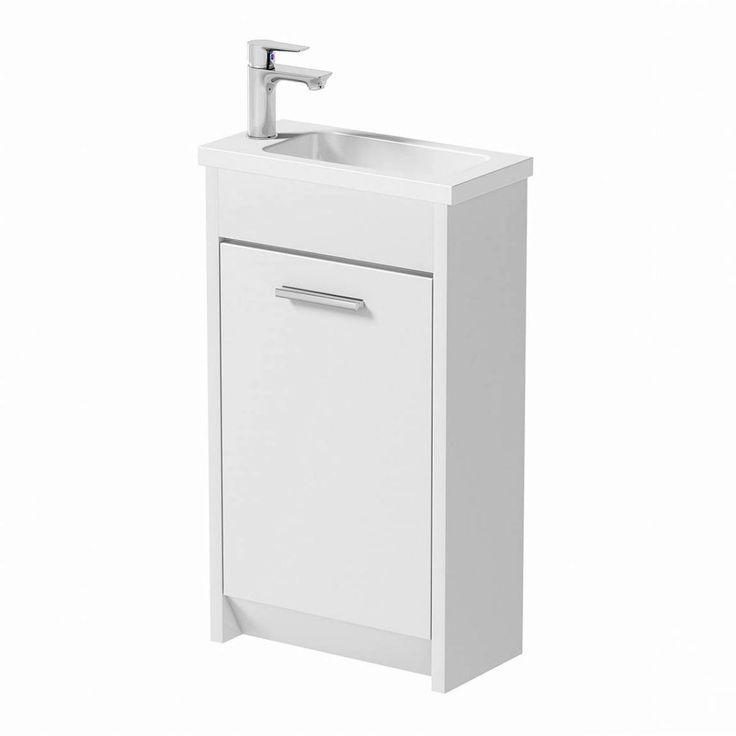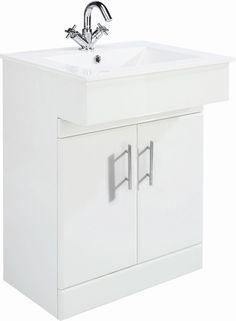The first image is the image on the left, the second image is the image on the right. Analyze the images presented: Is the assertion "The basin in the image on the left is set into a counter." valid? Answer yes or no. Yes. The first image is the image on the left, the second image is the image on the right. Considering the images on both sides, is "One of the sinks is an oval shape inset into a white rectangle, with no faucet mounted." valid? Answer yes or no. No. The first image is the image on the left, the second image is the image on the right. For the images displayed, is the sentence "One sink has a white rectangular recessed bowl and no faucet or spout mounted to it." factually correct? Answer yes or no. No. The first image is the image on the left, the second image is the image on the right. Considering the images on both sides, is "The sink in the image on the left is set into a counter." valid? Answer yes or no. Yes. 